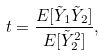Convert formula to latex. <formula><loc_0><loc_0><loc_500><loc_500>t = \frac { E [ \tilde { Y } _ { 1 } \tilde { Y } _ { 2 } ] } { E [ \tilde { Y } _ { 2 } ^ { 2 } ] } ,</formula> 